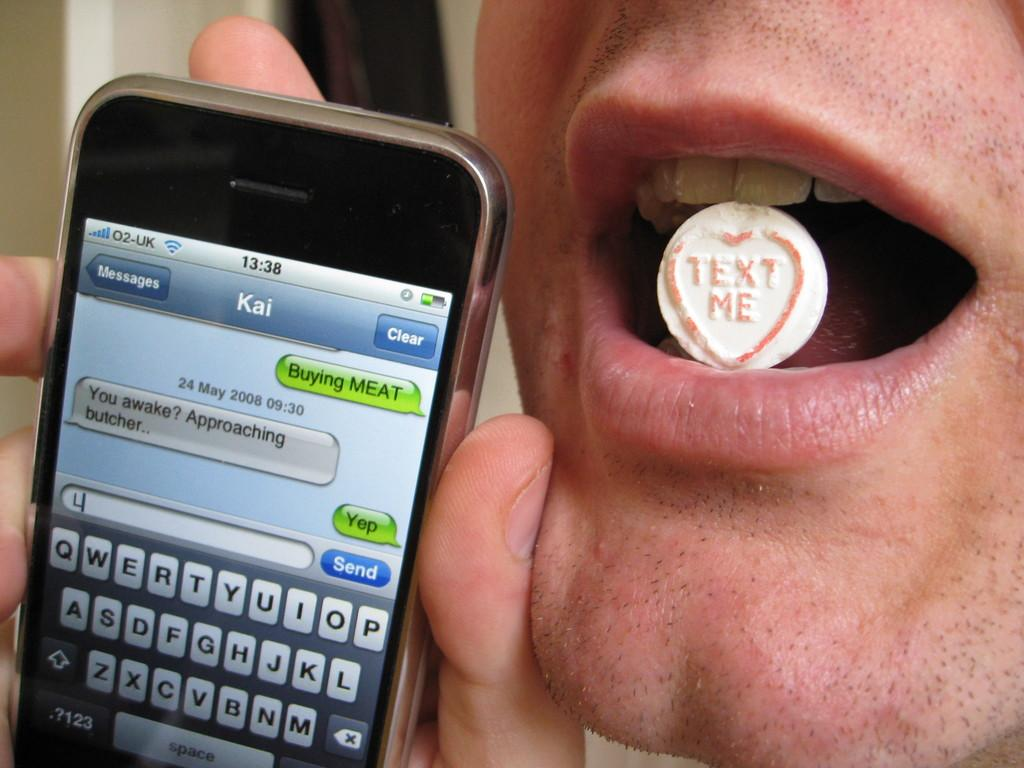<image>
Render a clear and concise summary of the photo. A person with a candy in his mouth is showing messages from a person named Kai. 